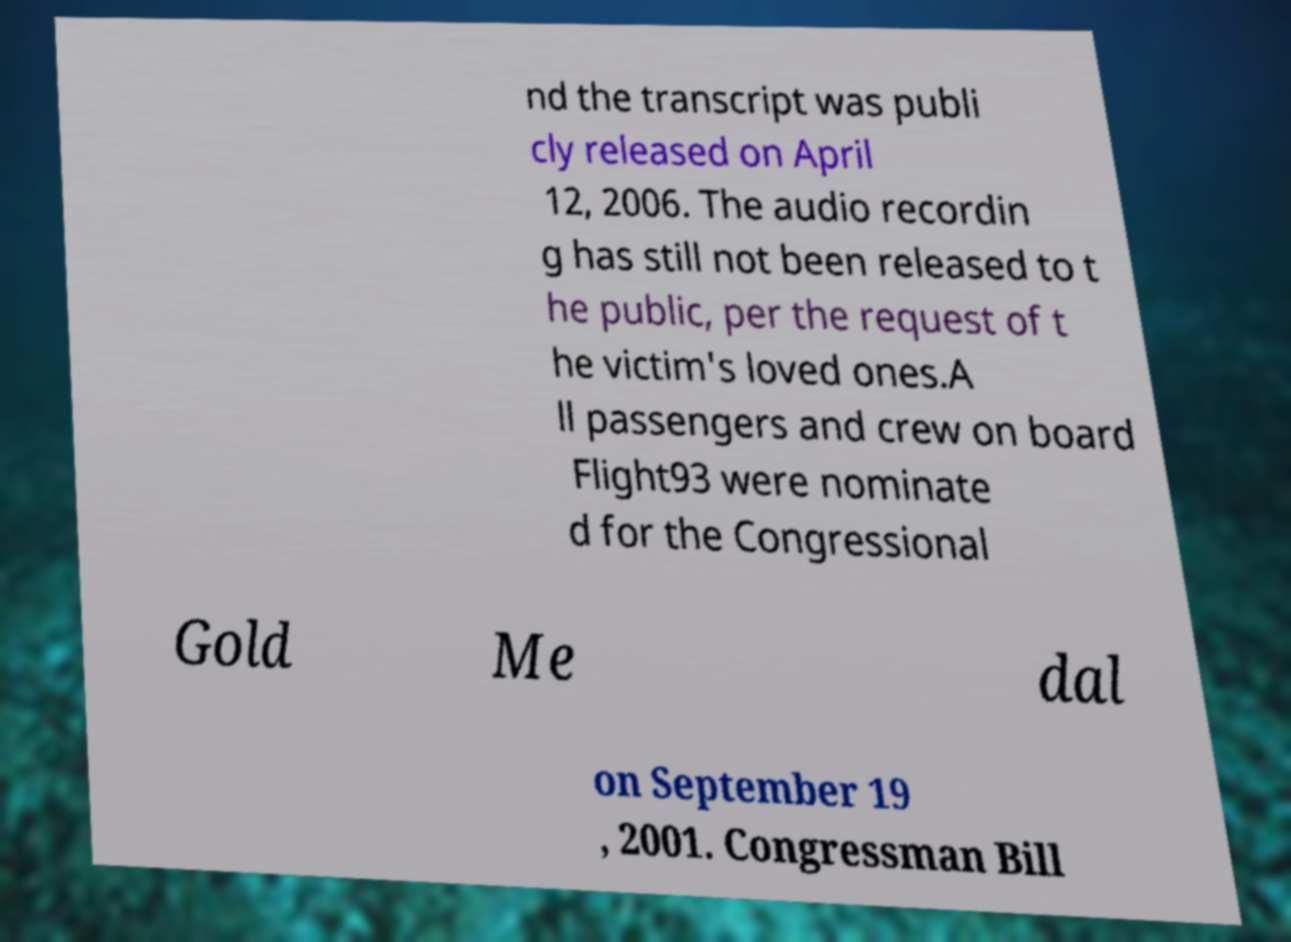Could you assist in decoding the text presented in this image and type it out clearly? nd the transcript was publi cly released on April 12, 2006. The audio recordin g has still not been released to t he public, per the request of t he victim's loved ones.A ll passengers and crew on board Flight93 were nominate d for the Congressional Gold Me dal on September 19 , 2001. Congressman Bill 